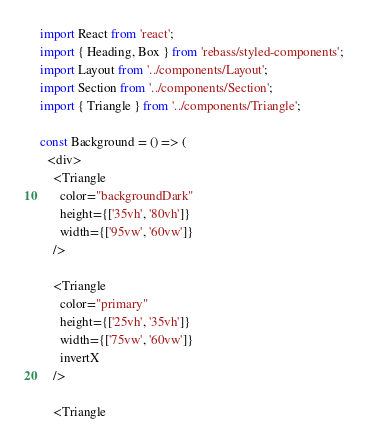Convert code to text. <code><loc_0><loc_0><loc_500><loc_500><_JavaScript_>import React from 'react';
import { Heading, Box } from 'rebass/styled-components';
import Layout from '../components/Layout';
import Section from '../components/Section';
import { Triangle } from '../components/Triangle';

const Background = () => (
  <div>
    <Triangle
      color="backgroundDark"
      height={['35vh', '80vh']}
      width={['95vw', '60vw']}
    />

    <Triangle
      color="primary"
      height={['25vh', '35vh']}
      width={['75vw', '60vw']}
      invertX
    />

    <Triangle</code> 